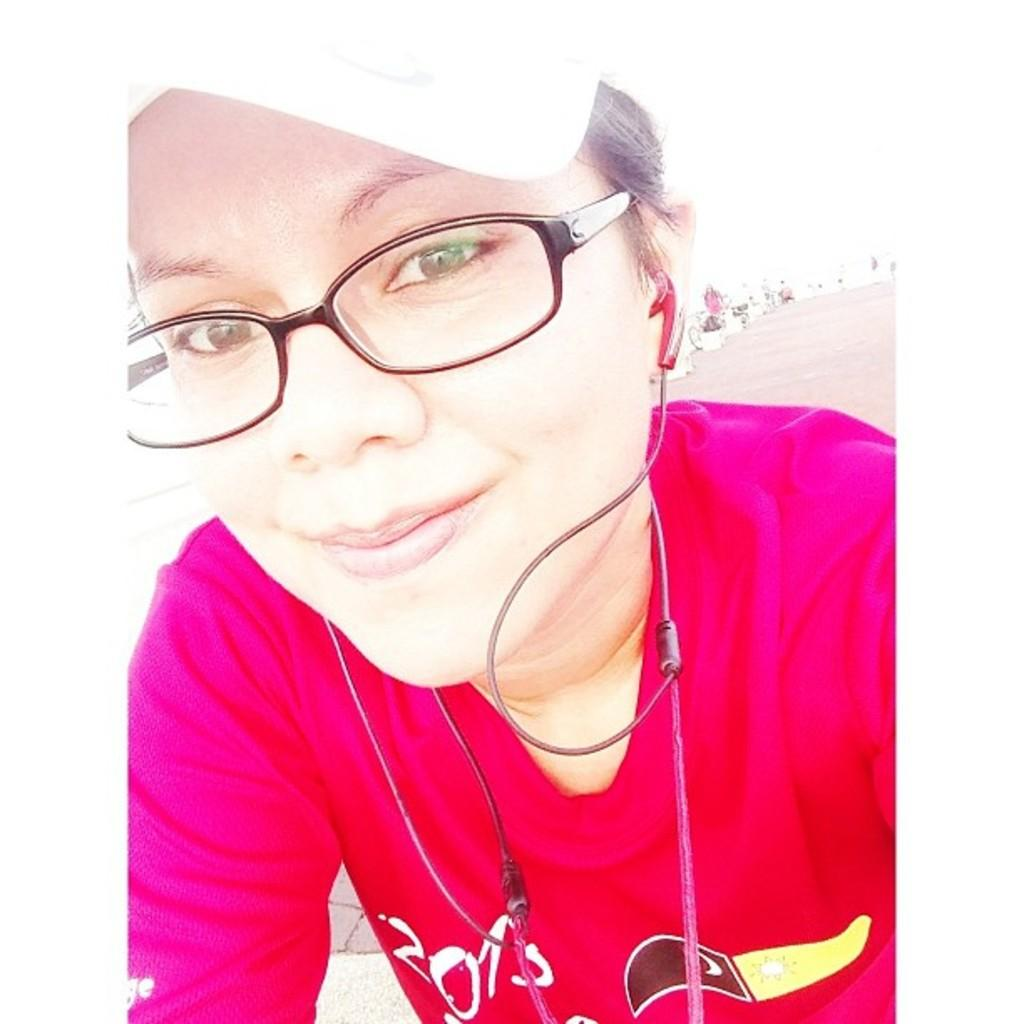Where was the image taken? The image was taken outdoors. Who is in the image? There is a girl in the image. What is the girl wearing on her upper body? The girl is wearing a T-shirt. What accessories is the girl wearing on her head? The girl is wearing a cap. What is the girl wearing on her face? The girl is wearing spectacles. What can be seen in the background of the image? There is a road in the background of the image. What type of metal tools does the carpenter have in the image? There is no carpenter or metal tools present in the image. How much weight is the porter carrying in the image? There is no porter or weight being carried in the image. 